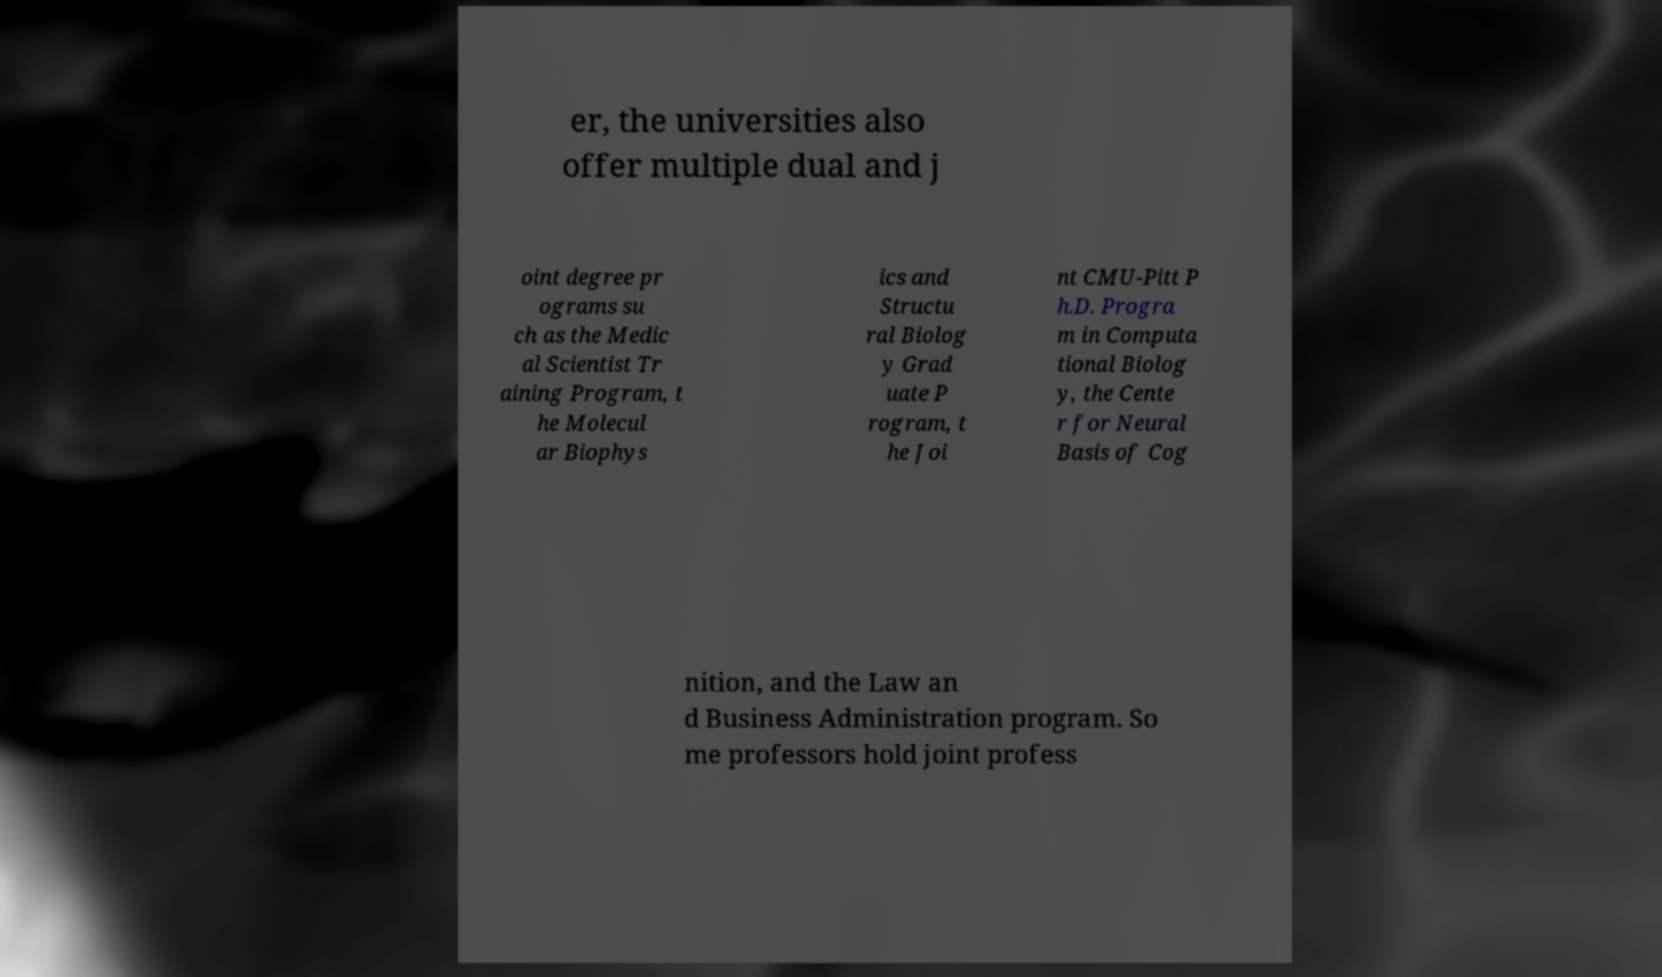Please read and relay the text visible in this image. What does it say? er, the universities also offer multiple dual and j oint degree pr ograms su ch as the Medic al Scientist Tr aining Program, t he Molecul ar Biophys ics and Structu ral Biolog y Grad uate P rogram, t he Joi nt CMU-Pitt P h.D. Progra m in Computa tional Biolog y, the Cente r for Neural Basis of Cog nition, and the Law an d Business Administration program. So me professors hold joint profess 